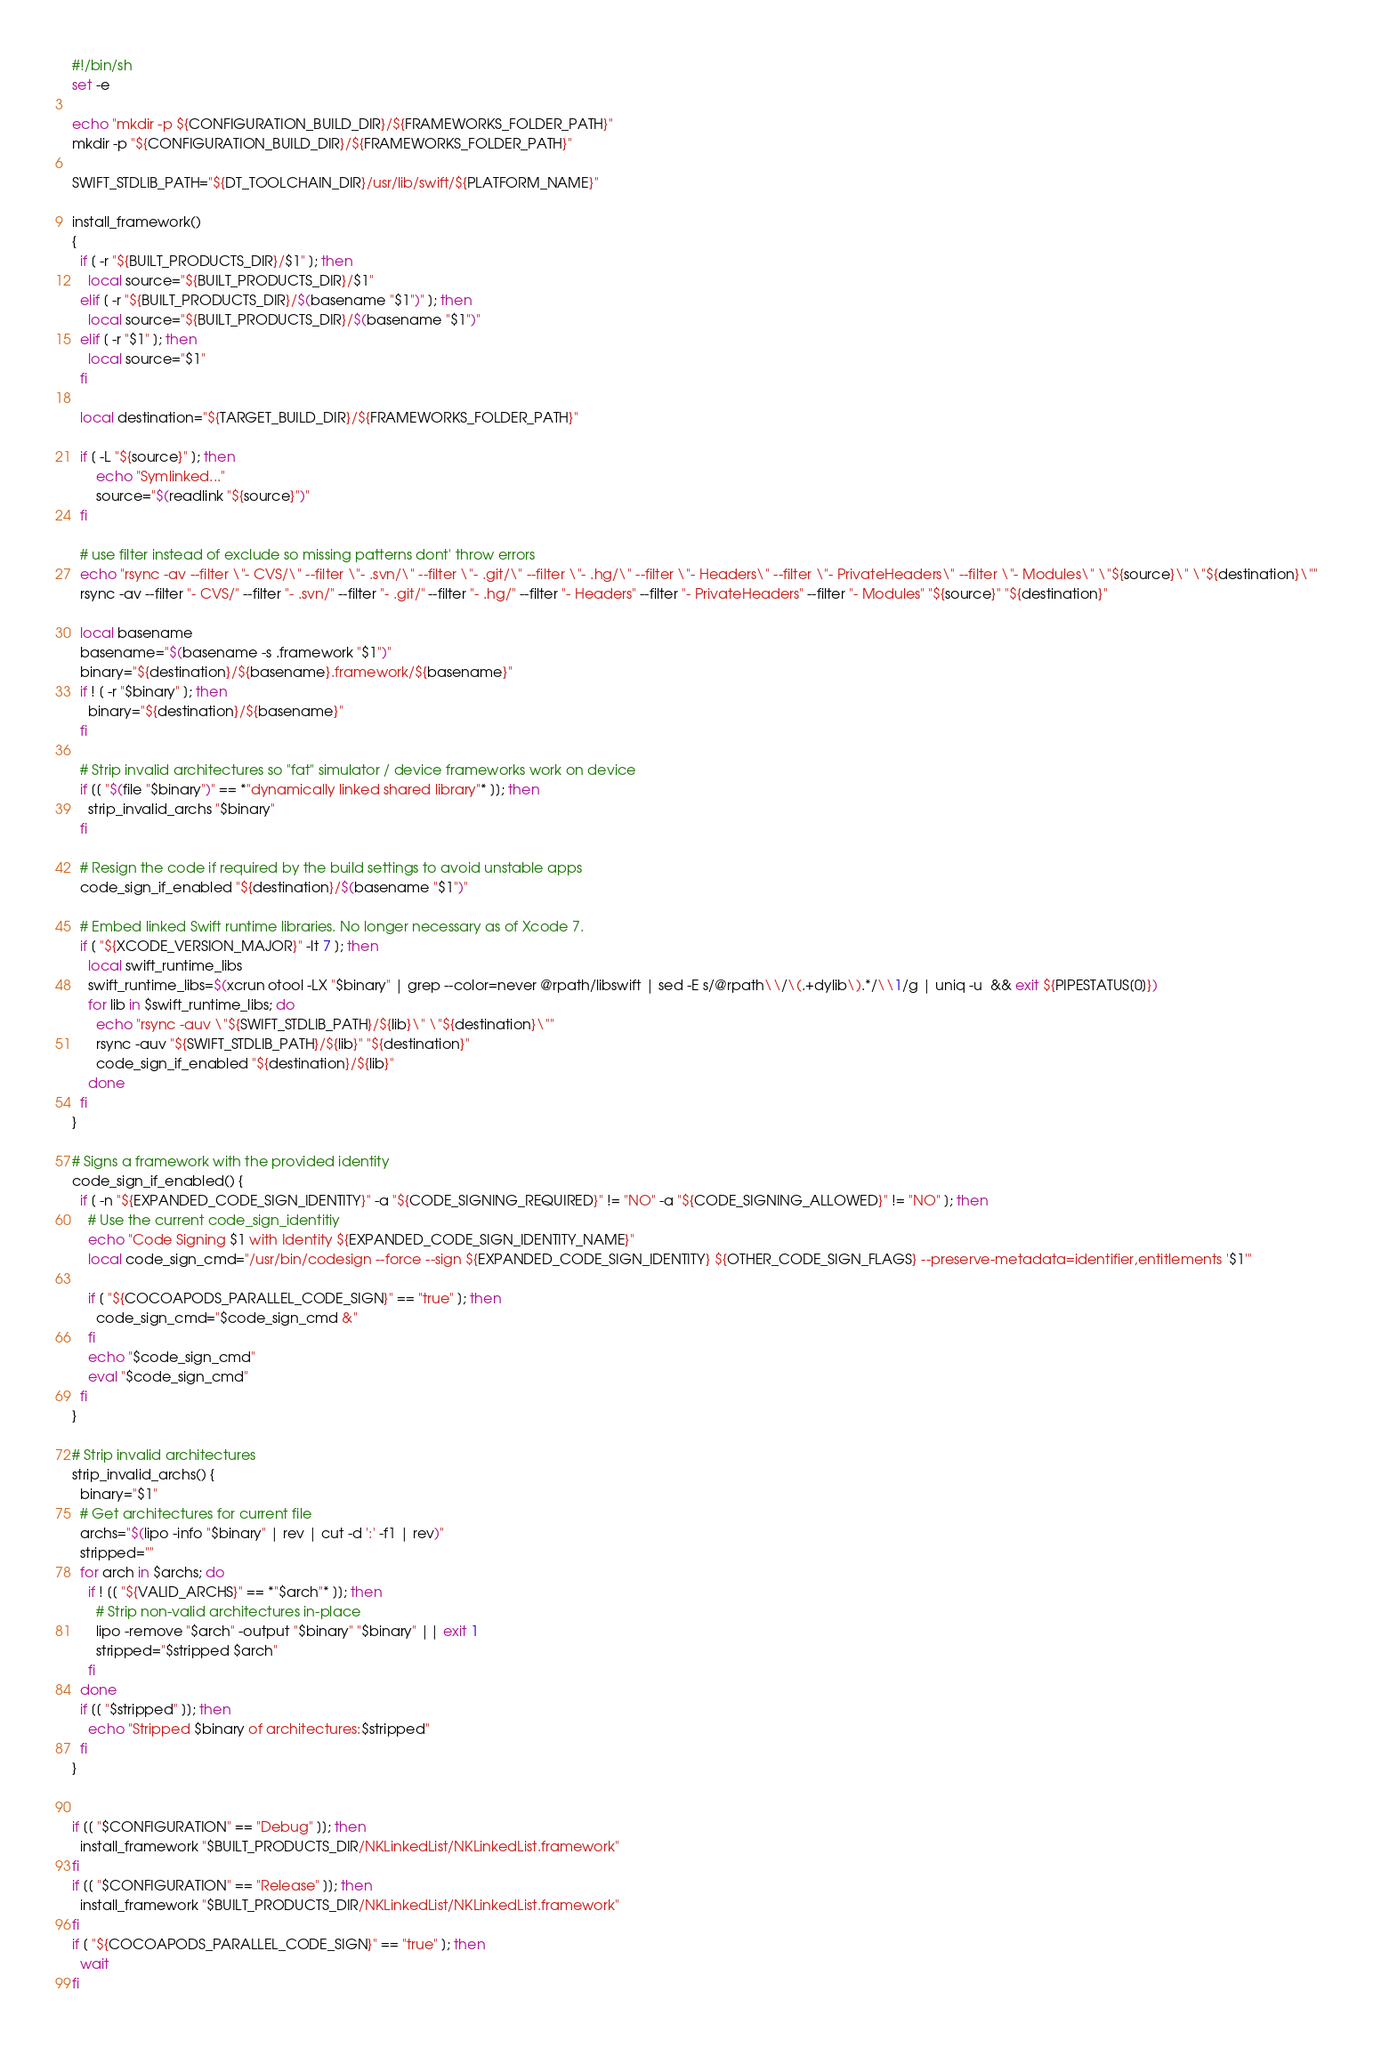Convert code to text. <code><loc_0><loc_0><loc_500><loc_500><_Bash_>#!/bin/sh
set -e

echo "mkdir -p ${CONFIGURATION_BUILD_DIR}/${FRAMEWORKS_FOLDER_PATH}"
mkdir -p "${CONFIGURATION_BUILD_DIR}/${FRAMEWORKS_FOLDER_PATH}"

SWIFT_STDLIB_PATH="${DT_TOOLCHAIN_DIR}/usr/lib/swift/${PLATFORM_NAME}"

install_framework()
{
  if [ -r "${BUILT_PRODUCTS_DIR}/$1" ]; then
    local source="${BUILT_PRODUCTS_DIR}/$1"
  elif [ -r "${BUILT_PRODUCTS_DIR}/$(basename "$1")" ]; then
    local source="${BUILT_PRODUCTS_DIR}/$(basename "$1")"
  elif [ -r "$1" ]; then
    local source="$1"
  fi

  local destination="${TARGET_BUILD_DIR}/${FRAMEWORKS_FOLDER_PATH}"

  if [ -L "${source}" ]; then
      echo "Symlinked..."
      source="$(readlink "${source}")"
  fi

  # use filter instead of exclude so missing patterns dont' throw errors
  echo "rsync -av --filter \"- CVS/\" --filter \"- .svn/\" --filter \"- .git/\" --filter \"- .hg/\" --filter \"- Headers\" --filter \"- PrivateHeaders\" --filter \"- Modules\" \"${source}\" \"${destination}\""
  rsync -av --filter "- CVS/" --filter "- .svn/" --filter "- .git/" --filter "- .hg/" --filter "- Headers" --filter "- PrivateHeaders" --filter "- Modules" "${source}" "${destination}"

  local basename
  basename="$(basename -s .framework "$1")"
  binary="${destination}/${basename}.framework/${basename}"
  if ! [ -r "$binary" ]; then
    binary="${destination}/${basename}"
  fi

  # Strip invalid architectures so "fat" simulator / device frameworks work on device
  if [[ "$(file "$binary")" == *"dynamically linked shared library"* ]]; then
    strip_invalid_archs "$binary"
  fi

  # Resign the code if required by the build settings to avoid unstable apps
  code_sign_if_enabled "${destination}/$(basename "$1")"

  # Embed linked Swift runtime libraries. No longer necessary as of Xcode 7.
  if [ "${XCODE_VERSION_MAJOR}" -lt 7 ]; then
    local swift_runtime_libs
    swift_runtime_libs=$(xcrun otool -LX "$binary" | grep --color=never @rpath/libswift | sed -E s/@rpath\\/\(.+dylib\).*/\\1/g | uniq -u  && exit ${PIPESTATUS[0]})
    for lib in $swift_runtime_libs; do
      echo "rsync -auv \"${SWIFT_STDLIB_PATH}/${lib}\" \"${destination}\""
      rsync -auv "${SWIFT_STDLIB_PATH}/${lib}" "${destination}"
      code_sign_if_enabled "${destination}/${lib}"
    done
  fi
}

# Signs a framework with the provided identity
code_sign_if_enabled() {
  if [ -n "${EXPANDED_CODE_SIGN_IDENTITY}" -a "${CODE_SIGNING_REQUIRED}" != "NO" -a "${CODE_SIGNING_ALLOWED}" != "NO" ]; then
    # Use the current code_sign_identitiy
    echo "Code Signing $1 with Identity ${EXPANDED_CODE_SIGN_IDENTITY_NAME}"
    local code_sign_cmd="/usr/bin/codesign --force --sign ${EXPANDED_CODE_SIGN_IDENTITY} ${OTHER_CODE_SIGN_FLAGS} --preserve-metadata=identifier,entitlements '$1'"

    if [ "${COCOAPODS_PARALLEL_CODE_SIGN}" == "true" ]; then
      code_sign_cmd="$code_sign_cmd &"
    fi
    echo "$code_sign_cmd"
    eval "$code_sign_cmd"
  fi
}

# Strip invalid architectures
strip_invalid_archs() {
  binary="$1"
  # Get architectures for current file
  archs="$(lipo -info "$binary" | rev | cut -d ':' -f1 | rev)"
  stripped=""
  for arch in $archs; do
    if ! [[ "${VALID_ARCHS}" == *"$arch"* ]]; then
      # Strip non-valid architectures in-place
      lipo -remove "$arch" -output "$binary" "$binary" || exit 1
      stripped="$stripped $arch"
    fi
  done
  if [[ "$stripped" ]]; then
    echo "Stripped $binary of architectures:$stripped"
  fi
}


if [[ "$CONFIGURATION" == "Debug" ]]; then
  install_framework "$BUILT_PRODUCTS_DIR/NKLinkedList/NKLinkedList.framework"
fi
if [[ "$CONFIGURATION" == "Release" ]]; then
  install_framework "$BUILT_PRODUCTS_DIR/NKLinkedList/NKLinkedList.framework"
fi
if [ "${COCOAPODS_PARALLEL_CODE_SIGN}" == "true" ]; then
  wait
fi
</code> 